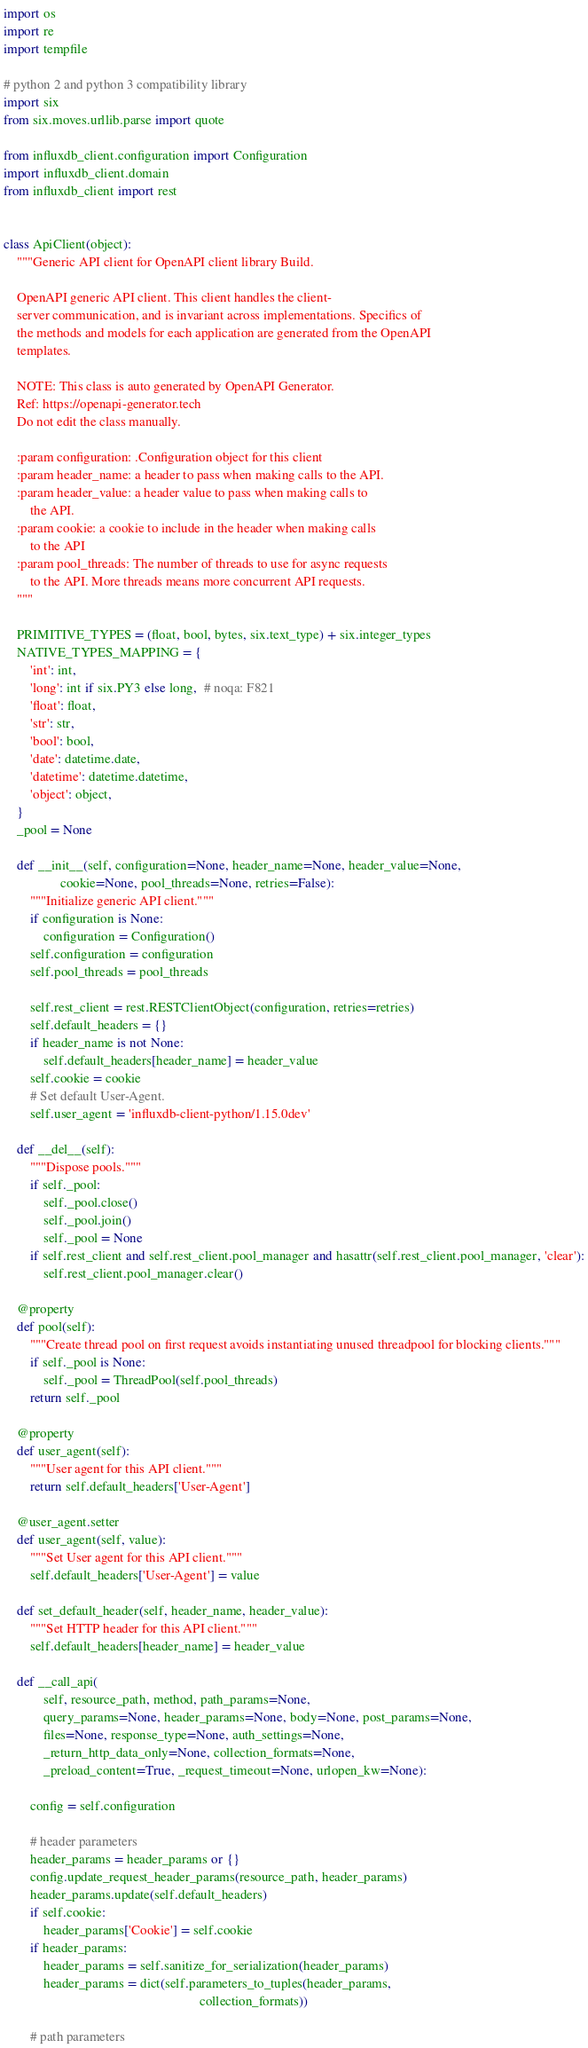Convert code to text. <code><loc_0><loc_0><loc_500><loc_500><_Python_>import os
import re
import tempfile

# python 2 and python 3 compatibility library
import six
from six.moves.urllib.parse import quote

from influxdb_client.configuration import Configuration
import influxdb_client.domain
from influxdb_client import rest


class ApiClient(object):
    """Generic API client for OpenAPI client library Build.

    OpenAPI generic API client. This client handles the client-
    server communication, and is invariant across implementations. Specifics of
    the methods and models for each application are generated from the OpenAPI
    templates.

    NOTE: This class is auto generated by OpenAPI Generator.
    Ref: https://openapi-generator.tech
    Do not edit the class manually.

    :param configuration: .Configuration object for this client
    :param header_name: a header to pass when making calls to the API.
    :param header_value: a header value to pass when making calls to
        the API.
    :param cookie: a cookie to include in the header when making calls
        to the API
    :param pool_threads: The number of threads to use for async requests
        to the API. More threads means more concurrent API requests.
    """

    PRIMITIVE_TYPES = (float, bool, bytes, six.text_type) + six.integer_types
    NATIVE_TYPES_MAPPING = {
        'int': int,
        'long': int if six.PY3 else long,  # noqa: F821
        'float': float,
        'str': str,
        'bool': bool,
        'date': datetime.date,
        'datetime': datetime.datetime,
        'object': object,
    }
    _pool = None

    def __init__(self, configuration=None, header_name=None, header_value=None,
                 cookie=None, pool_threads=None, retries=False):
        """Initialize generic API client."""
        if configuration is None:
            configuration = Configuration()
        self.configuration = configuration
        self.pool_threads = pool_threads

        self.rest_client = rest.RESTClientObject(configuration, retries=retries)
        self.default_headers = {}
        if header_name is not None:
            self.default_headers[header_name] = header_value
        self.cookie = cookie
        # Set default User-Agent.
        self.user_agent = 'influxdb-client-python/1.15.0dev'

    def __del__(self):
        """Dispose pools."""
        if self._pool:
            self._pool.close()
            self._pool.join()
            self._pool = None
        if self.rest_client and self.rest_client.pool_manager and hasattr(self.rest_client.pool_manager, 'clear'):
            self.rest_client.pool_manager.clear()

    @property
    def pool(self):
        """Create thread pool on first request avoids instantiating unused threadpool for blocking clients."""
        if self._pool is None:
            self._pool = ThreadPool(self.pool_threads)
        return self._pool

    @property
    def user_agent(self):
        """User agent for this API client."""
        return self.default_headers['User-Agent']

    @user_agent.setter
    def user_agent(self, value):
        """Set User agent for this API client."""
        self.default_headers['User-Agent'] = value

    def set_default_header(self, header_name, header_value):
        """Set HTTP header for this API client."""
        self.default_headers[header_name] = header_value

    def __call_api(
            self, resource_path, method, path_params=None,
            query_params=None, header_params=None, body=None, post_params=None,
            files=None, response_type=None, auth_settings=None,
            _return_http_data_only=None, collection_formats=None,
            _preload_content=True, _request_timeout=None, urlopen_kw=None):

        config = self.configuration

        # header parameters
        header_params = header_params or {}
        config.update_request_header_params(resource_path, header_params)
        header_params.update(self.default_headers)
        if self.cookie:
            header_params['Cookie'] = self.cookie
        if header_params:
            header_params = self.sanitize_for_serialization(header_params)
            header_params = dict(self.parameters_to_tuples(header_params,
                                                           collection_formats))

        # path parameters</code> 